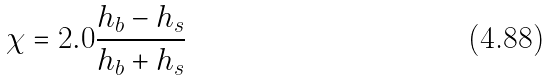Convert formula to latex. <formula><loc_0><loc_0><loc_500><loc_500>\chi = 2 . 0 \frac { h _ { b } - h _ { s } } { h _ { b } + h _ { s } }</formula> 